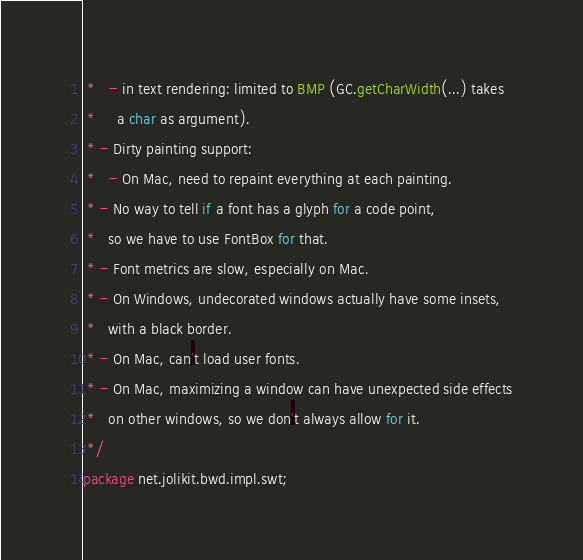Convert code to text. <code><loc_0><loc_0><loc_500><loc_500><_Java_> *   - in text rendering: limited to BMP (GC.getCharWidth(...) takes
 *     a char as argument).
 * - Dirty painting support:
 *   - On Mac, need to repaint everything at each painting.
 * - No way to tell if a font has a glyph for a code point,
 *   so we have to use FontBox for that.
 * - Font metrics are slow, especially on Mac.
 * - On Windows, undecorated windows actually have some insets,
 *   with a black border.
 * - On Mac, can't load user fonts.
 * - On Mac, maximizing a window can have unexpected side effects
 *   on other windows, so we don't always allow for it.
 */
package net.jolikit.bwd.impl.swt;
</code> 